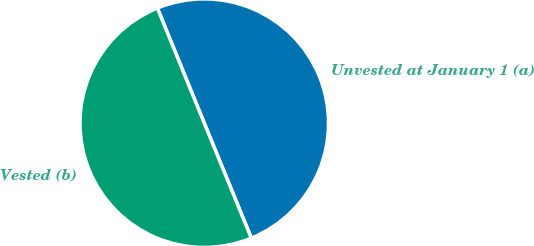Convert chart to OTSL. <chart><loc_0><loc_0><loc_500><loc_500><pie_chart><fcel>Unvested at January 1 (a)<fcel>Vested (b)<nl><fcel>49.98%<fcel>50.02%<nl></chart> 